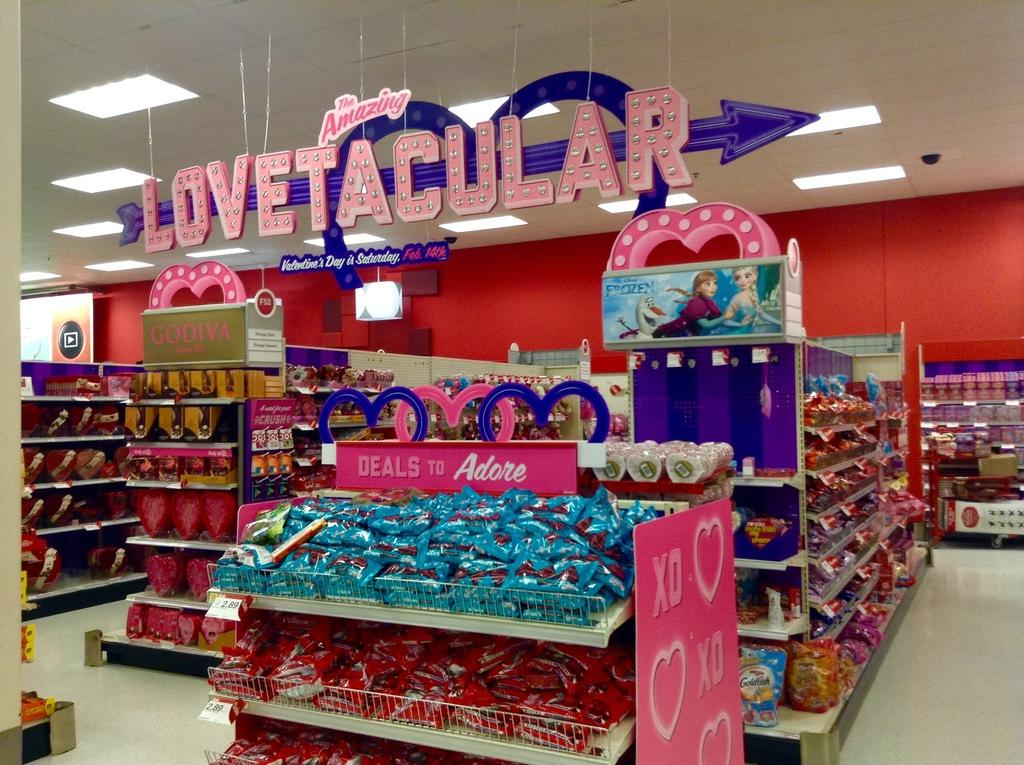What types of items are visible in the image? There are packets and boxes in the image. Where are the packets and boxes located? The packets and boxes are placed in a shelf. What else can be seen in the image besides the packets and boxes? There are lights on the roof in the image. What type of cloud can be seen in the image? There is no cloud present in the image; it features packets, boxes, a shelf, and lights on the roof. 